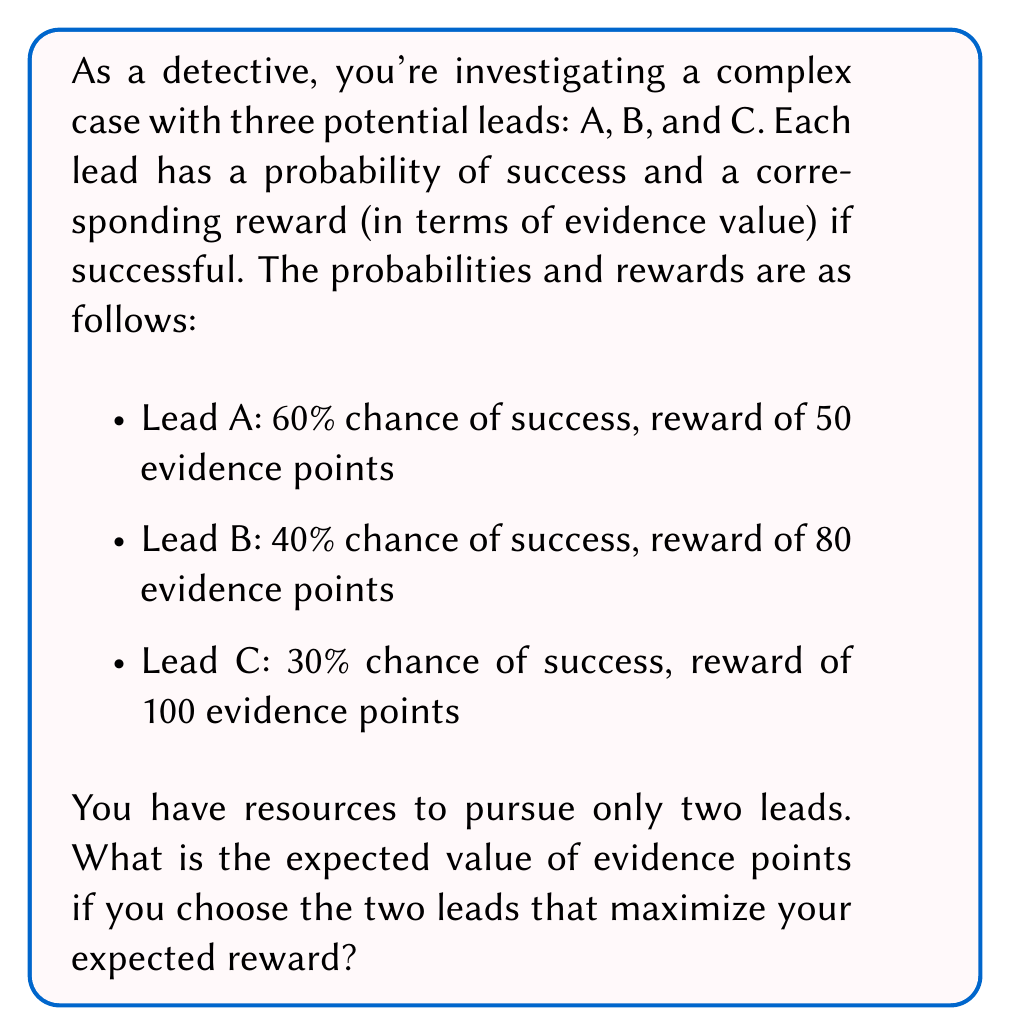What is the answer to this math problem? To solve this problem, we need to calculate the expected value for each lead and then choose the two leads with the highest expected values.

1. Calculate the expected value for each lead:

   Lead A: $E(A) = 0.60 \times 50 = 30$ evidence points
   Lead B: $E(B) = 0.40 \times 80 = 32$ evidence points
   Lead C: $E(C) = 0.30 \times 100 = 30$ evidence points

2. Rank the leads based on their expected values:
   B (32) > A (30) = C (30)

3. Choose the two leads with the highest expected values: B and either A or C (since they have equal expected values, we can choose either one).

4. Calculate the total expected value:
   $E(\text{total}) = E(B) + E(A) = 32 + 30 = 62$ evidence points

   or

   $E(\text{total}) = E(B) + E(C) = 32 + 30 = 62$ evidence points

Therefore, the maximum expected value of evidence points is 62, achieved by pursuing Lead B and either Lead A or Lead C.
Answer: 62 evidence points 